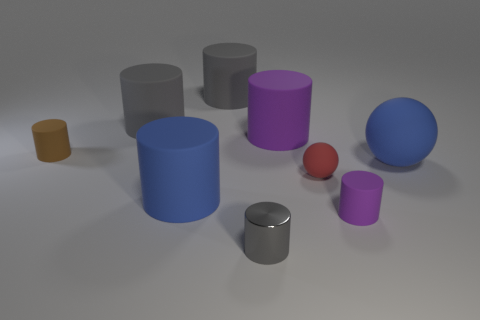How many other objects are there of the same material as the tiny purple object?
Your response must be concise. 7. There is a small purple matte object; is its shape the same as the big blue matte thing left of the large purple rubber cylinder?
Make the answer very short. Yes. How many large objects are gray cylinders or metal things?
Your response must be concise. 2. There is a matte object that is the same color as the big ball; what size is it?
Make the answer very short. Large. The small cylinder on the left side of the big rubber thing that is in front of the tiny red sphere is what color?
Make the answer very short. Brown. Does the brown cylinder have the same material as the large blue thing that is in front of the tiny red thing?
Your response must be concise. Yes. There is a blue thing that is to the right of the blue rubber cylinder; what material is it?
Offer a very short reply. Rubber. Are there an equal number of big gray rubber cylinders that are left of the tiny brown matte cylinder and big purple objects?
Your answer should be compact. No. What material is the big thing that is on the right side of the purple thing in front of the small brown thing?
Give a very brief answer. Rubber. What is the shape of the matte object that is both on the right side of the red object and on the left side of the large blue ball?
Provide a succinct answer. Cylinder. 